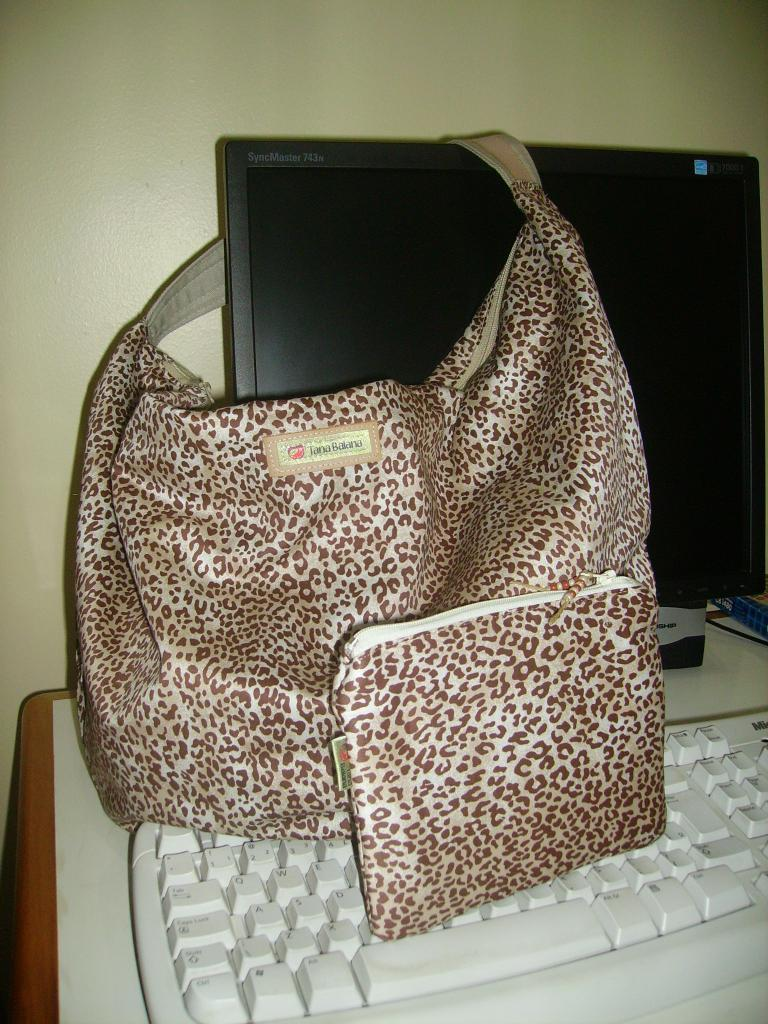What type of electronic device is visible in the image? There is a keyboard and a monitor in the image. What other objects can be seen on the table in the image? There is a handbag and a pouch on the table in the image. Can you describe the location of these objects? All these objects are on a table in the image. Where is the faucet located in the image? There is no faucet present in the image. What type of vein can be seen in the image? There are no veins visible in the image. 